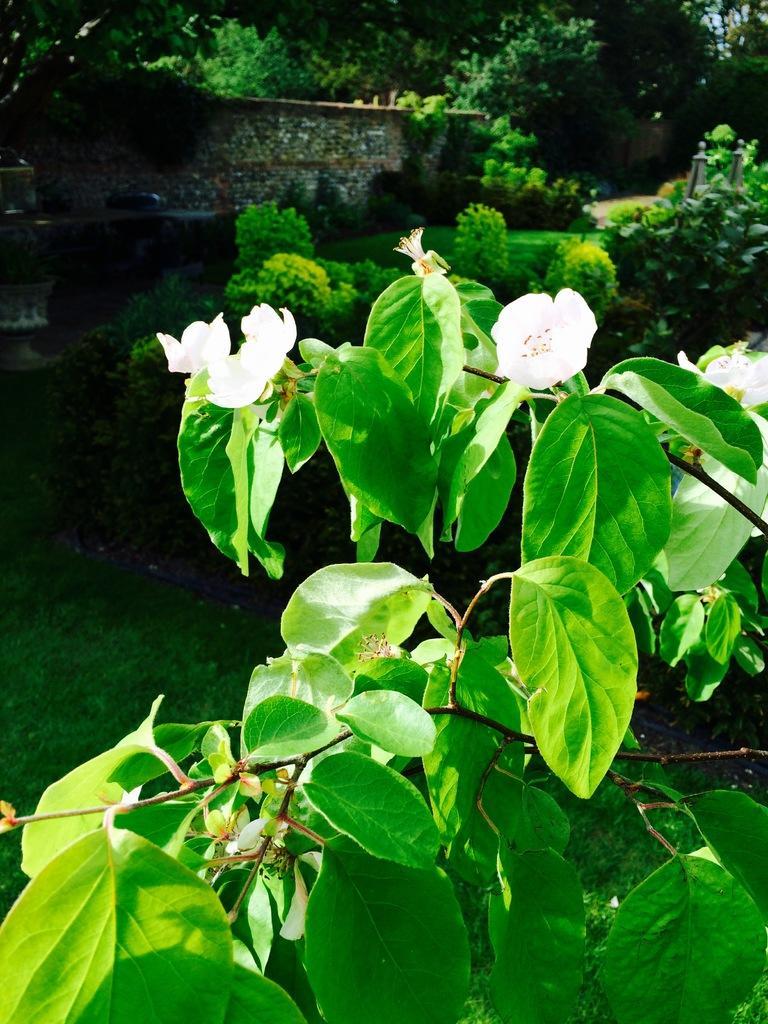How would you summarize this image in a sentence or two? In this picture I can see a plant with white color flowers, and in the background there are plants, a wall and trees. 